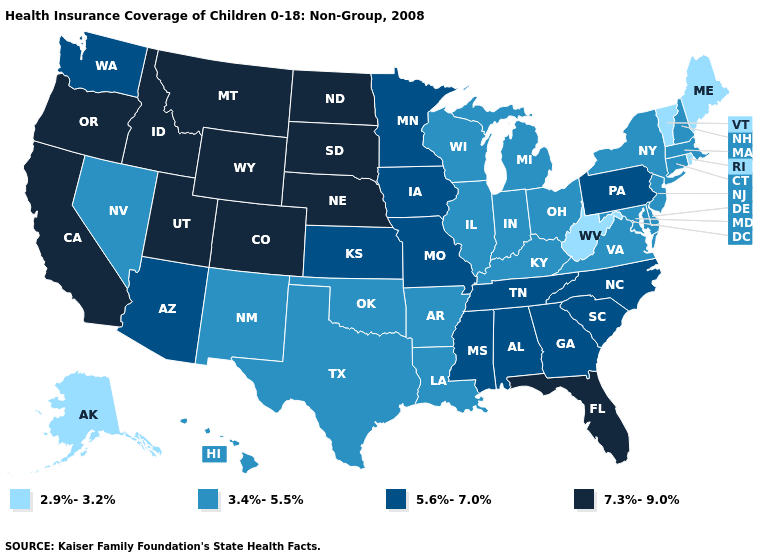Does the first symbol in the legend represent the smallest category?
Answer briefly. Yes. How many symbols are there in the legend?
Answer briefly. 4. What is the value of Nevada?
Answer briefly. 3.4%-5.5%. Name the states that have a value in the range 3.4%-5.5%?
Quick response, please. Arkansas, Connecticut, Delaware, Hawaii, Illinois, Indiana, Kentucky, Louisiana, Maryland, Massachusetts, Michigan, Nevada, New Hampshire, New Jersey, New Mexico, New York, Ohio, Oklahoma, Texas, Virginia, Wisconsin. What is the value of Maine?
Give a very brief answer. 2.9%-3.2%. Does Colorado have the lowest value in the USA?
Concise answer only. No. Does Alaska have the lowest value in the USA?
Short answer required. Yes. Which states hav the highest value in the South?
Write a very short answer. Florida. What is the value of Connecticut?
Give a very brief answer. 3.4%-5.5%. Which states have the highest value in the USA?
Keep it brief. California, Colorado, Florida, Idaho, Montana, Nebraska, North Dakota, Oregon, South Dakota, Utah, Wyoming. Name the states that have a value in the range 5.6%-7.0%?
Short answer required. Alabama, Arizona, Georgia, Iowa, Kansas, Minnesota, Mississippi, Missouri, North Carolina, Pennsylvania, South Carolina, Tennessee, Washington. What is the value of Maine?
Keep it brief. 2.9%-3.2%. Does the map have missing data?
Keep it brief. No. 